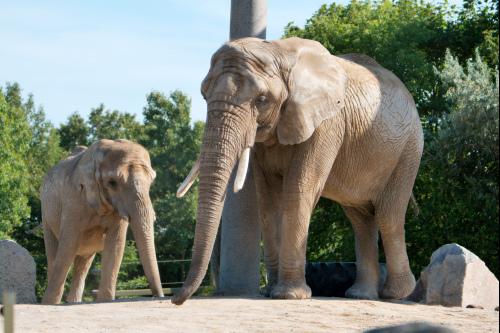Are the animals real?
Write a very short answer. Yes. Are the animals wild?
Be succinct. No. What are these animals?
Write a very short answer. Elephants. 